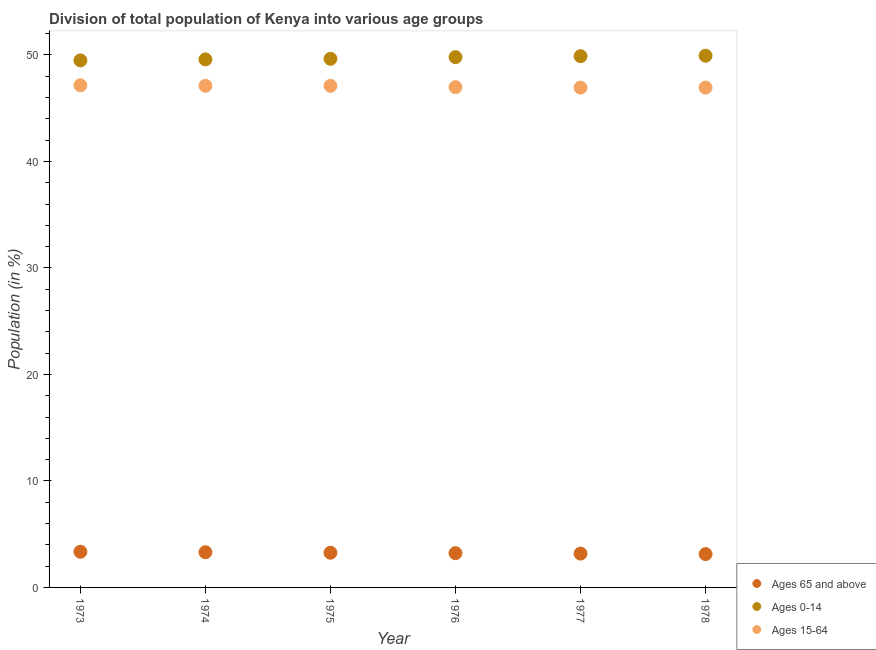How many different coloured dotlines are there?
Offer a very short reply. 3. What is the percentage of population within the age-group 15-64 in 1978?
Give a very brief answer. 46.94. Across all years, what is the maximum percentage of population within the age-group 15-64?
Make the answer very short. 47.15. Across all years, what is the minimum percentage of population within the age-group 0-14?
Your answer should be very brief. 49.49. In which year was the percentage of population within the age-group of 65 and above maximum?
Give a very brief answer. 1973. In which year was the percentage of population within the age-group of 65 and above minimum?
Your answer should be compact. 1978. What is the total percentage of population within the age-group of 65 and above in the graph?
Make the answer very short. 19.44. What is the difference between the percentage of population within the age-group 15-64 in 1974 and that in 1978?
Offer a very short reply. 0.17. What is the difference between the percentage of population within the age-group 15-64 in 1976 and the percentage of population within the age-group 0-14 in 1977?
Make the answer very short. -2.91. What is the average percentage of population within the age-group 0-14 per year?
Keep it short and to the point. 49.72. In the year 1974, what is the difference between the percentage of population within the age-group 0-14 and percentage of population within the age-group of 65 and above?
Provide a short and direct response. 46.28. In how many years, is the percentage of population within the age-group 0-14 greater than 32 %?
Offer a terse response. 6. What is the ratio of the percentage of population within the age-group 0-14 in 1973 to that in 1978?
Your answer should be compact. 0.99. Is the difference between the percentage of population within the age-group 0-14 in 1976 and 1977 greater than the difference between the percentage of population within the age-group of 65 and above in 1976 and 1977?
Your answer should be compact. No. What is the difference between the highest and the second highest percentage of population within the age-group 0-14?
Offer a terse response. 0.04. What is the difference between the highest and the lowest percentage of population within the age-group of 65 and above?
Provide a short and direct response. 0.22. Is the sum of the percentage of population within the age-group 15-64 in 1973 and 1977 greater than the maximum percentage of population within the age-group 0-14 across all years?
Ensure brevity in your answer.  Yes. Does the percentage of population within the age-group 15-64 monotonically increase over the years?
Your answer should be compact. No. Is the percentage of population within the age-group 0-14 strictly less than the percentage of population within the age-group 15-64 over the years?
Give a very brief answer. No. Does the graph contain any zero values?
Provide a short and direct response. No. Does the graph contain grids?
Your response must be concise. No. What is the title of the graph?
Keep it short and to the point. Division of total population of Kenya into various age groups
. What is the Population (in %) in Ages 65 and above in 1973?
Provide a short and direct response. 3.35. What is the Population (in %) of Ages 0-14 in 1973?
Ensure brevity in your answer.  49.49. What is the Population (in %) of Ages 15-64 in 1973?
Your response must be concise. 47.15. What is the Population (in %) of Ages 65 and above in 1974?
Make the answer very short. 3.31. What is the Population (in %) of Ages 0-14 in 1974?
Keep it short and to the point. 49.59. What is the Population (in %) of Ages 15-64 in 1974?
Make the answer very short. 47.11. What is the Population (in %) of Ages 65 and above in 1975?
Your response must be concise. 3.26. What is the Population (in %) of Ages 0-14 in 1975?
Provide a short and direct response. 49.64. What is the Population (in %) in Ages 15-64 in 1975?
Your answer should be compact. 47.1. What is the Population (in %) in Ages 65 and above in 1976?
Give a very brief answer. 3.22. What is the Population (in %) of Ages 0-14 in 1976?
Your answer should be compact. 49.8. What is the Population (in %) of Ages 15-64 in 1976?
Ensure brevity in your answer.  46.98. What is the Population (in %) in Ages 65 and above in 1977?
Make the answer very short. 3.18. What is the Population (in %) in Ages 0-14 in 1977?
Ensure brevity in your answer.  49.89. What is the Population (in %) in Ages 15-64 in 1977?
Your response must be concise. 46.94. What is the Population (in %) of Ages 65 and above in 1978?
Ensure brevity in your answer.  3.13. What is the Population (in %) of Ages 0-14 in 1978?
Provide a short and direct response. 49.93. What is the Population (in %) of Ages 15-64 in 1978?
Offer a terse response. 46.94. Across all years, what is the maximum Population (in %) in Ages 65 and above?
Provide a succinct answer. 3.35. Across all years, what is the maximum Population (in %) of Ages 0-14?
Keep it short and to the point. 49.93. Across all years, what is the maximum Population (in %) of Ages 15-64?
Provide a short and direct response. 47.15. Across all years, what is the minimum Population (in %) of Ages 65 and above?
Your response must be concise. 3.13. Across all years, what is the minimum Population (in %) of Ages 0-14?
Your answer should be very brief. 49.49. Across all years, what is the minimum Population (in %) in Ages 15-64?
Your answer should be compact. 46.94. What is the total Population (in %) of Ages 65 and above in the graph?
Your answer should be very brief. 19.44. What is the total Population (in %) of Ages 0-14 in the graph?
Your response must be concise. 298.34. What is the total Population (in %) of Ages 15-64 in the graph?
Give a very brief answer. 282.22. What is the difference between the Population (in %) in Ages 65 and above in 1973 and that in 1974?
Offer a very short reply. 0.04. What is the difference between the Population (in %) in Ages 0-14 in 1973 and that in 1974?
Keep it short and to the point. -0.09. What is the difference between the Population (in %) in Ages 15-64 in 1973 and that in 1974?
Offer a terse response. 0.05. What is the difference between the Population (in %) of Ages 65 and above in 1973 and that in 1975?
Make the answer very short. 0.09. What is the difference between the Population (in %) of Ages 0-14 in 1973 and that in 1975?
Give a very brief answer. -0.15. What is the difference between the Population (in %) of Ages 15-64 in 1973 and that in 1975?
Make the answer very short. 0.05. What is the difference between the Population (in %) of Ages 65 and above in 1973 and that in 1976?
Your answer should be very brief. 0.13. What is the difference between the Population (in %) of Ages 0-14 in 1973 and that in 1976?
Provide a succinct answer. -0.31. What is the difference between the Population (in %) in Ages 15-64 in 1973 and that in 1976?
Keep it short and to the point. 0.17. What is the difference between the Population (in %) of Ages 65 and above in 1973 and that in 1977?
Offer a terse response. 0.17. What is the difference between the Population (in %) of Ages 0-14 in 1973 and that in 1977?
Provide a short and direct response. -0.39. What is the difference between the Population (in %) in Ages 15-64 in 1973 and that in 1977?
Provide a short and direct response. 0.22. What is the difference between the Population (in %) in Ages 65 and above in 1973 and that in 1978?
Make the answer very short. 0.22. What is the difference between the Population (in %) in Ages 0-14 in 1973 and that in 1978?
Your answer should be very brief. -0.44. What is the difference between the Population (in %) in Ages 15-64 in 1973 and that in 1978?
Offer a terse response. 0.22. What is the difference between the Population (in %) in Ages 65 and above in 1974 and that in 1975?
Keep it short and to the point. 0.05. What is the difference between the Population (in %) in Ages 0-14 in 1974 and that in 1975?
Ensure brevity in your answer.  -0.06. What is the difference between the Population (in %) in Ages 15-64 in 1974 and that in 1975?
Your answer should be very brief. 0.01. What is the difference between the Population (in %) in Ages 65 and above in 1974 and that in 1976?
Make the answer very short. 0.09. What is the difference between the Population (in %) in Ages 0-14 in 1974 and that in 1976?
Ensure brevity in your answer.  -0.21. What is the difference between the Population (in %) in Ages 15-64 in 1974 and that in 1976?
Provide a succinct answer. 0.13. What is the difference between the Population (in %) in Ages 65 and above in 1974 and that in 1977?
Keep it short and to the point. 0.13. What is the difference between the Population (in %) in Ages 0-14 in 1974 and that in 1977?
Your response must be concise. -0.3. What is the difference between the Population (in %) in Ages 15-64 in 1974 and that in 1977?
Offer a very short reply. 0.17. What is the difference between the Population (in %) in Ages 65 and above in 1974 and that in 1978?
Your answer should be very brief. 0.18. What is the difference between the Population (in %) of Ages 0-14 in 1974 and that in 1978?
Your answer should be very brief. -0.34. What is the difference between the Population (in %) of Ages 15-64 in 1974 and that in 1978?
Your answer should be compact. 0.17. What is the difference between the Population (in %) in Ages 65 and above in 1975 and that in 1976?
Provide a short and direct response. 0.04. What is the difference between the Population (in %) in Ages 0-14 in 1975 and that in 1976?
Offer a terse response. -0.16. What is the difference between the Population (in %) in Ages 15-64 in 1975 and that in 1976?
Your answer should be compact. 0.12. What is the difference between the Population (in %) of Ages 65 and above in 1975 and that in 1977?
Your answer should be very brief. 0.08. What is the difference between the Population (in %) of Ages 0-14 in 1975 and that in 1977?
Your response must be concise. -0.25. What is the difference between the Population (in %) of Ages 15-64 in 1975 and that in 1977?
Provide a short and direct response. 0.16. What is the difference between the Population (in %) of Ages 65 and above in 1975 and that in 1978?
Offer a terse response. 0.13. What is the difference between the Population (in %) of Ages 0-14 in 1975 and that in 1978?
Offer a very short reply. -0.29. What is the difference between the Population (in %) of Ages 15-64 in 1975 and that in 1978?
Keep it short and to the point. 0.16. What is the difference between the Population (in %) of Ages 65 and above in 1976 and that in 1977?
Your response must be concise. 0.04. What is the difference between the Population (in %) in Ages 0-14 in 1976 and that in 1977?
Offer a terse response. -0.09. What is the difference between the Population (in %) in Ages 15-64 in 1976 and that in 1977?
Your response must be concise. 0.05. What is the difference between the Population (in %) of Ages 65 and above in 1976 and that in 1978?
Offer a terse response. 0.09. What is the difference between the Population (in %) in Ages 0-14 in 1976 and that in 1978?
Keep it short and to the point. -0.13. What is the difference between the Population (in %) in Ages 15-64 in 1976 and that in 1978?
Provide a succinct answer. 0.04. What is the difference between the Population (in %) in Ages 65 and above in 1977 and that in 1978?
Offer a terse response. 0.05. What is the difference between the Population (in %) of Ages 0-14 in 1977 and that in 1978?
Offer a very short reply. -0.04. What is the difference between the Population (in %) in Ages 15-64 in 1977 and that in 1978?
Offer a very short reply. -0. What is the difference between the Population (in %) in Ages 65 and above in 1973 and the Population (in %) in Ages 0-14 in 1974?
Ensure brevity in your answer.  -46.24. What is the difference between the Population (in %) in Ages 65 and above in 1973 and the Population (in %) in Ages 15-64 in 1974?
Your response must be concise. -43.76. What is the difference between the Population (in %) of Ages 0-14 in 1973 and the Population (in %) of Ages 15-64 in 1974?
Your response must be concise. 2.39. What is the difference between the Population (in %) in Ages 65 and above in 1973 and the Population (in %) in Ages 0-14 in 1975?
Give a very brief answer. -46.29. What is the difference between the Population (in %) of Ages 65 and above in 1973 and the Population (in %) of Ages 15-64 in 1975?
Give a very brief answer. -43.75. What is the difference between the Population (in %) of Ages 0-14 in 1973 and the Population (in %) of Ages 15-64 in 1975?
Provide a succinct answer. 2.39. What is the difference between the Population (in %) in Ages 65 and above in 1973 and the Population (in %) in Ages 0-14 in 1976?
Your answer should be very brief. -46.45. What is the difference between the Population (in %) of Ages 65 and above in 1973 and the Population (in %) of Ages 15-64 in 1976?
Offer a very short reply. -43.63. What is the difference between the Population (in %) of Ages 0-14 in 1973 and the Population (in %) of Ages 15-64 in 1976?
Your answer should be compact. 2.51. What is the difference between the Population (in %) in Ages 65 and above in 1973 and the Population (in %) in Ages 0-14 in 1977?
Your answer should be compact. -46.54. What is the difference between the Population (in %) in Ages 65 and above in 1973 and the Population (in %) in Ages 15-64 in 1977?
Your response must be concise. -43.58. What is the difference between the Population (in %) in Ages 0-14 in 1973 and the Population (in %) in Ages 15-64 in 1977?
Your answer should be very brief. 2.56. What is the difference between the Population (in %) in Ages 65 and above in 1973 and the Population (in %) in Ages 0-14 in 1978?
Give a very brief answer. -46.58. What is the difference between the Population (in %) in Ages 65 and above in 1973 and the Population (in %) in Ages 15-64 in 1978?
Give a very brief answer. -43.59. What is the difference between the Population (in %) in Ages 0-14 in 1973 and the Population (in %) in Ages 15-64 in 1978?
Your answer should be very brief. 2.56. What is the difference between the Population (in %) in Ages 65 and above in 1974 and the Population (in %) in Ages 0-14 in 1975?
Your response must be concise. -46.34. What is the difference between the Population (in %) in Ages 65 and above in 1974 and the Population (in %) in Ages 15-64 in 1975?
Keep it short and to the point. -43.79. What is the difference between the Population (in %) in Ages 0-14 in 1974 and the Population (in %) in Ages 15-64 in 1975?
Keep it short and to the point. 2.49. What is the difference between the Population (in %) in Ages 65 and above in 1974 and the Population (in %) in Ages 0-14 in 1976?
Your response must be concise. -46.49. What is the difference between the Population (in %) of Ages 65 and above in 1974 and the Population (in %) of Ages 15-64 in 1976?
Provide a succinct answer. -43.68. What is the difference between the Population (in %) of Ages 0-14 in 1974 and the Population (in %) of Ages 15-64 in 1976?
Provide a succinct answer. 2.61. What is the difference between the Population (in %) in Ages 65 and above in 1974 and the Population (in %) in Ages 0-14 in 1977?
Offer a very short reply. -46.58. What is the difference between the Population (in %) of Ages 65 and above in 1974 and the Population (in %) of Ages 15-64 in 1977?
Give a very brief answer. -43.63. What is the difference between the Population (in %) of Ages 0-14 in 1974 and the Population (in %) of Ages 15-64 in 1977?
Provide a succinct answer. 2.65. What is the difference between the Population (in %) of Ages 65 and above in 1974 and the Population (in %) of Ages 0-14 in 1978?
Offer a very short reply. -46.62. What is the difference between the Population (in %) of Ages 65 and above in 1974 and the Population (in %) of Ages 15-64 in 1978?
Give a very brief answer. -43.63. What is the difference between the Population (in %) in Ages 0-14 in 1974 and the Population (in %) in Ages 15-64 in 1978?
Offer a very short reply. 2.65. What is the difference between the Population (in %) in Ages 65 and above in 1975 and the Population (in %) in Ages 0-14 in 1976?
Keep it short and to the point. -46.54. What is the difference between the Population (in %) in Ages 65 and above in 1975 and the Population (in %) in Ages 15-64 in 1976?
Your answer should be compact. -43.72. What is the difference between the Population (in %) of Ages 0-14 in 1975 and the Population (in %) of Ages 15-64 in 1976?
Ensure brevity in your answer.  2.66. What is the difference between the Population (in %) in Ages 65 and above in 1975 and the Population (in %) in Ages 0-14 in 1977?
Your answer should be very brief. -46.63. What is the difference between the Population (in %) in Ages 65 and above in 1975 and the Population (in %) in Ages 15-64 in 1977?
Your answer should be very brief. -43.68. What is the difference between the Population (in %) in Ages 0-14 in 1975 and the Population (in %) in Ages 15-64 in 1977?
Your response must be concise. 2.71. What is the difference between the Population (in %) in Ages 65 and above in 1975 and the Population (in %) in Ages 0-14 in 1978?
Provide a succinct answer. -46.67. What is the difference between the Population (in %) in Ages 65 and above in 1975 and the Population (in %) in Ages 15-64 in 1978?
Your answer should be compact. -43.68. What is the difference between the Population (in %) of Ages 0-14 in 1975 and the Population (in %) of Ages 15-64 in 1978?
Your response must be concise. 2.7. What is the difference between the Population (in %) of Ages 65 and above in 1976 and the Population (in %) of Ages 0-14 in 1977?
Make the answer very short. -46.67. What is the difference between the Population (in %) of Ages 65 and above in 1976 and the Population (in %) of Ages 15-64 in 1977?
Make the answer very short. -43.72. What is the difference between the Population (in %) in Ages 0-14 in 1976 and the Population (in %) in Ages 15-64 in 1977?
Give a very brief answer. 2.86. What is the difference between the Population (in %) in Ages 65 and above in 1976 and the Population (in %) in Ages 0-14 in 1978?
Your answer should be compact. -46.71. What is the difference between the Population (in %) in Ages 65 and above in 1976 and the Population (in %) in Ages 15-64 in 1978?
Make the answer very short. -43.72. What is the difference between the Population (in %) of Ages 0-14 in 1976 and the Population (in %) of Ages 15-64 in 1978?
Offer a terse response. 2.86. What is the difference between the Population (in %) in Ages 65 and above in 1977 and the Population (in %) in Ages 0-14 in 1978?
Ensure brevity in your answer.  -46.75. What is the difference between the Population (in %) of Ages 65 and above in 1977 and the Population (in %) of Ages 15-64 in 1978?
Provide a succinct answer. -43.76. What is the difference between the Population (in %) of Ages 0-14 in 1977 and the Population (in %) of Ages 15-64 in 1978?
Your response must be concise. 2.95. What is the average Population (in %) in Ages 65 and above per year?
Your response must be concise. 3.24. What is the average Population (in %) in Ages 0-14 per year?
Your response must be concise. 49.72. What is the average Population (in %) in Ages 15-64 per year?
Give a very brief answer. 47.04. In the year 1973, what is the difference between the Population (in %) in Ages 65 and above and Population (in %) in Ages 0-14?
Your answer should be compact. -46.14. In the year 1973, what is the difference between the Population (in %) of Ages 65 and above and Population (in %) of Ages 15-64?
Your answer should be compact. -43.8. In the year 1973, what is the difference between the Population (in %) in Ages 0-14 and Population (in %) in Ages 15-64?
Offer a very short reply. 2.34. In the year 1974, what is the difference between the Population (in %) of Ages 65 and above and Population (in %) of Ages 0-14?
Provide a short and direct response. -46.28. In the year 1974, what is the difference between the Population (in %) of Ages 65 and above and Population (in %) of Ages 15-64?
Offer a very short reply. -43.8. In the year 1974, what is the difference between the Population (in %) in Ages 0-14 and Population (in %) in Ages 15-64?
Ensure brevity in your answer.  2.48. In the year 1975, what is the difference between the Population (in %) in Ages 65 and above and Population (in %) in Ages 0-14?
Your answer should be compact. -46.39. In the year 1975, what is the difference between the Population (in %) in Ages 65 and above and Population (in %) in Ages 15-64?
Provide a short and direct response. -43.84. In the year 1975, what is the difference between the Population (in %) in Ages 0-14 and Population (in %) in Ages 15-64?
Ensure brevity in your answer.  2.54. In the year 1976, what is the difference between the Population (in %) of Ages 65 and above and Population (in %) of Ages 0-14?
Ensure brevity in your answer.  -46.58. In the year 1976, what is the difference between the Population (in %) in Ages 65 and above and Population (in %) in Ages 15-64?
Your response must be concise. -43.76. In the year 1976, what is the difference between the Population (in %) of Ages 0-14 and Population (in %) of Ages 15-64?
Ensure brevity in your answer.  2.82. In the year 1977, what is the difference between the Population (in %) of Ages 65 and above and Population (in %) of Ages 0-14?
Offer a terse response. -46.71. In the year 1977, what is the difference between the Population (in %) of Ages 65 and above and Population (in %) of Ages 15-64?
Keep it short and to the point. -43.76. In the year 1977, what is the difference between the Population (in %) of Ages 0-14 and Population (in %) of Ages 15-64?
Keep it short and to the point. 2.95. In the year 1978, what is the difference between the Population (in %) of Ages 65 and above and Population (in %) of Ages 0-14?
Your answer should be compact. -46.8. In the year 1978, what is the difference between the Population (in %) in Ages 65 and above and Population (in %) in Ages 15-64?
Give a very brief answer. -43.81. In the year 1978, what is the difference between the Population (in %) of Ages 0-14 and Population (in %) of Ages 15-64?
Give a very brief answer. 2.99. What is the ratio of the Population (in %) of Ages 65 and above in 1973 to that in 1974?
Keep it short and to the point. 1.01. What is the ratio of the Population (in %) in Ages 0-14 in 1973 to that in 1974?
Provide a short and direct response. 1. What is the ratio of the Population (in %) in Ages 65 and above in 1973 to that in 1975?
Your response must be concise. 1.03. What is the ratio of the Population (in %) in Ages 0-14 in 1973 to that in 1975?
Your answer should be compact. 1. What is the ratio of the Population (in %) in Ages 15-64 in 1973 to that in 1975?
Offer a terse response. 1. What is the ratio of the Population (in %) of Ages 65 and above in 1973 to that in 1976?
Your response must be concise. 1.04. What is the ratio of the Population (in %) in Ages 0-14 in 1973 to that in 1976?
Your answer should be compact. 0.99. What is the ratio of the Population (in %) in Ages 15-64 in 1973 to that in 1976?
Offer a terse response. 1. What is the ratio of the Population (in %) of Ages 65 and above in 1973 to that in 1977?
Provide a succinct answer. 1.05. What is the ratio of the Population (in %) of Ages 15-64 in 1973 to that in 1977?
Your answer should be compact. 1. What is the ratio of the Population (in %) in Ages 65 and above in 1973 to that in 1978?
Offer a very short reply. 1.07. What is the ratio of the Population (in %) of Ages 15-64 in 1973 to that in 1978?
Give a very brief answer. 1. What is the ratio of the Population (in %) in Ages 65 and above in 1974 to that in 1975?
Your answer should be compact. 1.02. What is the ratio of the Population (in %) of Ages 15-64 in 1974 to that in 1975?
Provide a short and direct response. 1. What is the ratio of the Population (in %) of Ages 65 and above in 1974 to that in 1976?
Keep it short and to the point. 1.03. What is the ratio of the Population (in %) of Ages 65 and above in 1974 to that in 1977?
Give a very brief answer. 1.04. What is the ratio of the Population (in %) of Ages 65 and above in 1974 to that in 1978?
Make the answer very short. 1.06. What is the ratio of the Population (in %) of Ages 65 and above in 1975 to that in 1976?
Your response must be concise. 1.01. What is the ratio of the Population (in %) of Ages 0-14 in 1975 to that in 1976?
Keep it short and to the point. 1. What is the ratio of the Population (in %) in Ages 15-64 in 1975 to that in 1976?
Your answer should be very brief. 1. What is the ratio of the Population (in %) in Ages 65 and above in 1975 to that in 1977?
Your answer should be compact. 1.03. What is the ratio of the Population (in %) in Ages 0-14 in 1975 to that in 1977?
Keep it short and to the point. 1. What is the ratio of the Population (in %) of Ages 15-64 in 1975 to that in 1977?
Ensure brevity in your answer.  1. What is the ratio of the Population (in %) of Ages 65 and above in 1975 to that in 1978?
Make the answer very short. 1.04. What is the ratio of the Population (in %) in Ages 15-64 in 1975 to that in 1978?
Make the answer very short. 1. What is the ratio of the Population (in %) of Ages 65 and above in 1976 to that in 1977?
Give a very brief answer. 1.01. What is the ratio of the Population (in %) of Ages 0-14 in 1976 to that in 1977?
Give a very brief answer. 1. What is the ratio of the Population (in %) of Ages 15-64 in 1976 to that in 1977?
Keep it short and to the point. 1. What is the ratio of the Population (in %) in Ages 65 and above in 1976 to that in 1978?
Keep it short and to the point. 1.03. What is the ratio of the Population (in %) of Ages 0-14 in 1976 to that in 1978?
Offer a very short reply. 1. What is the ratio of the Population (in %) of Ages 15-64 in 1976 to that in 1978?
Offer a terse response. 1. What is the ratio of the Population (in %) of Ages 65 and above in 1977 to that in 1978?
Give a very brief answer. 1.01. What is the ratio of the Population (in %) in Ages 15-64 in 1977 to that in 1978?
Your answer should be compact. 1. What is the difference between the highest and the second highest Population (in %) in Ages 65 and above?
Ensure brevity in your answer.  0.04. What is the difference between the highest and the second highest Population (in %) in Ages 0-14?
Your answer should be very brief. 0.04. What is the difference between the highest and the second highest Population (in %) in Ages 15-64?
Ensure brevity in your answer.  0.05. What is the difference between the highest and the lowest Population (in %) of Ages 65 and above?
Provide a short and direct response. 0.22. What is the difference between the highest and the lowest Population (in %) in Ages 0-14?
Your answer should be compact. 0.44. What is the difference between the highest and the lowest Population (in %) in Ages 15-64?
Ensure brevity in your answer.  0.22. 